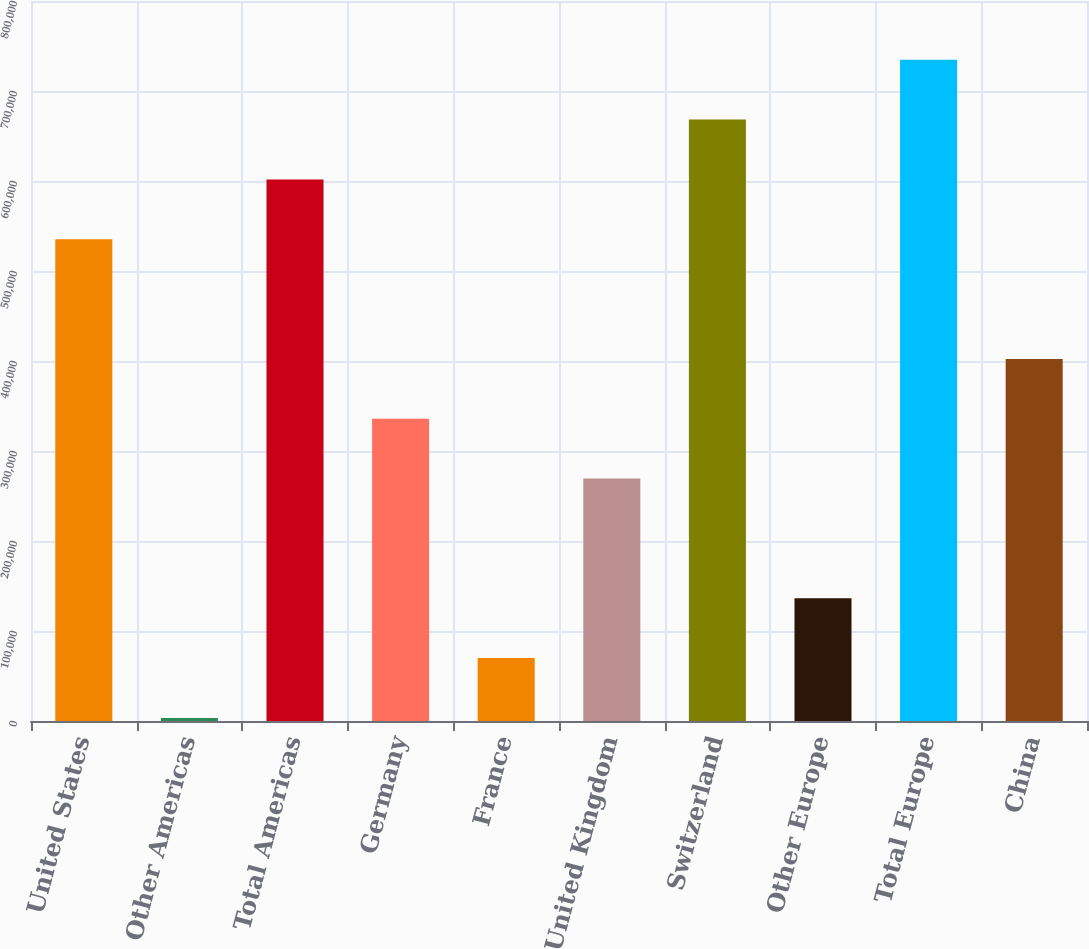<chart> <loc_0><loc_0><loc_500><loc_500><bar_chart><fcel>United States<fcel>Other Americas<fcel>Total Americas<fcel>Germany<fcel>France<fcel>United Kingdom<fcel>Switzerland<fcel>Other Europe<fcel>Total Europe<fcel>China<nl><fcel>535298<fcel>3406<fcel>601784<fcel>335838<fcel>69892.5<fcel>269352<fcel>668271<fcel>136379<fcel>734758<fcel>402325<nl></chart> 